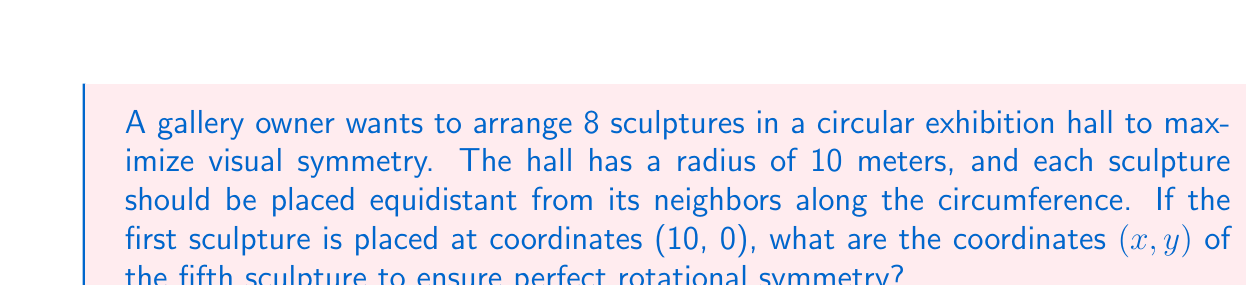Show me your answer to this math problem. To solve this problem, we'll follow these steps:

1) First, we need to calculate the angle between each sculpture. Since there are 8 sculptures, and they form a complete circle (360°), the angle between each sculpture is:

   $$\theta = \frac{360°}{8} = 45°$$

2) The fifth sculpture will be positioned 4 steps away from the first one (as 1 to 5 is 4 steps in a circular arrangement). So, the total angle from the first sculpture to the fifth is:

   $$4 \times 45° = 180°$$

3) Now, we can use trigonometric functions to find the coordinates. In a unit circle:
   - x-coordinate is given by $\cos(\theta)$
   - y-coordinate is given by $\sin(\theta)$

4) However, our circle has a radius of 10 meters, so we need to multiply these by 10:

   $$x = 10 \times \cos(180°)$$
   $$y = 10 \times \sin(180°)$$

5) Calculating these values:
   $$x = 10 \times (-1) = -10$$
   $$y = 10 \times 0 = 0$$

Therefore, the coordinates of the fifth sculpture are (-10, 0).
Answer: (-10, 0) 